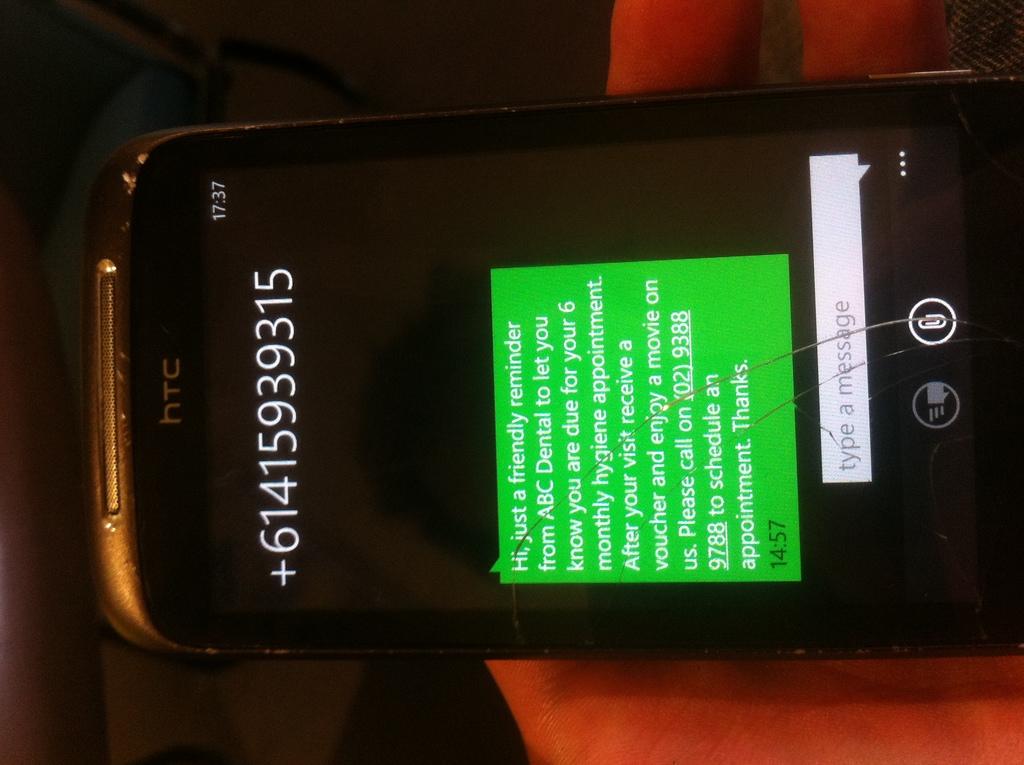What brand of phone is this?
Ensure brevity in your answer.  Htc. What is the phone number on the screen?
Your response must be concise. 61415939315. 